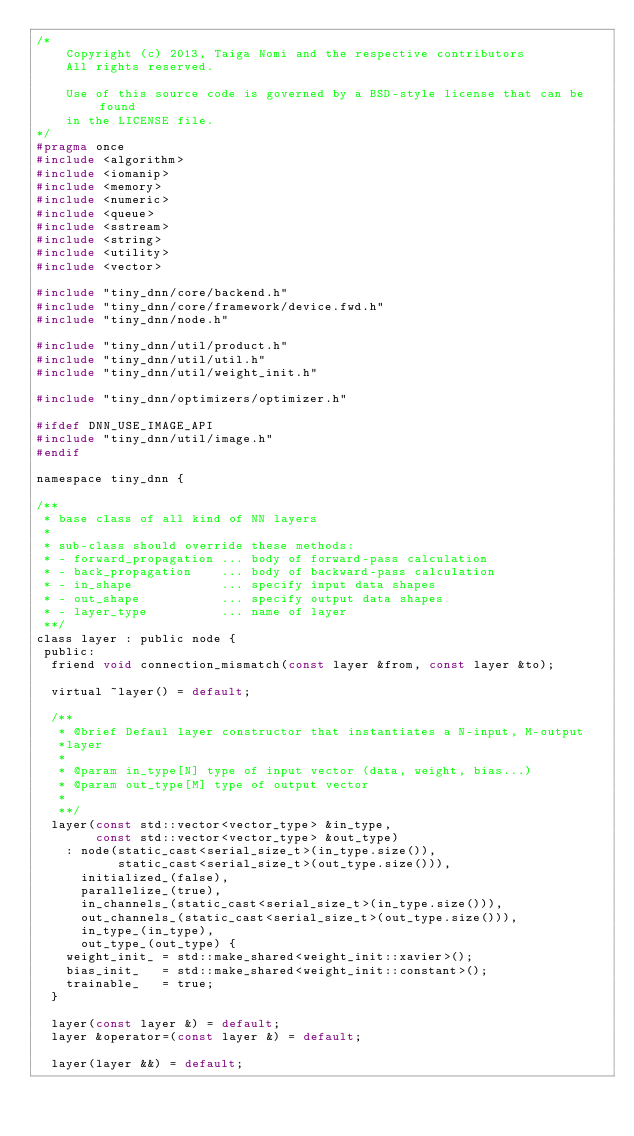<code> <loc_0><loc_0><loc_500><loc_500><_C_>/*
    Copyright (c) 2013, Taiga Nomi and the respective contributors
    All rights reserved.

    Use of this source code is governed by a BSD-style license that can be found
    in the LICENSE file.
*/
#pragma once
#include <algorithm>
#include <iomanip>
#include <memory>
#include <numeric>
#include <queue>
#include <sstream>
#include <string>
#include <utility>
#include <vector>

#include "tiny_dnn/core/backend.h"
#include "tiny_dnn/core/framework/device.fwd.h"
#include "tiny_dnn/node.h"

#include "tiny_dnn/util/product.h"
#include "tiny_dnn/util/util.h"
#include "tiny_dnn/util/weight_init.h"

#include "tiny_dnn/optimizers/optimizer.h"

#ifdef DNN_USE_IMAGE_API
#include "tiny_dnn/util/image.h"
#endif

namespace tiny_dnn {

/**
 * base class of all kind of NN layers
 *
 * sub-class should override these methods:
 * - forward_propagation ... body of forward-pass calculation
 * - back_propagation    ... body of backward-pass calculation
 * - in_shape            ... specify input data shapes
 * - out_shape           ... specify output data shapes
 * - layer_type          ... name of layer
 **/
class layer : public node {
 public:
  friend void connection_mismatch(const layer &from, const layer &to);

  virtual ~layer() = default;

  /**
   * @brief Defaul layer constructor that instantiates a N-input, M-output
   *layer
   *
   * @param in_type[N] type of input vector (data, weight, bias...)
   * @param out_type[M] type of output vector
   *
   **/
  layer(const std::vector<vector_type> &in_type,
        const std::vector<vector_type> &out_type)
    : node(static_cast<serial_size_t>(in_type.size()),
           static_cast<serial_size_t>(out_type.size())),
      initialized_(false),
      parallelize_(true),
      in_channels_(static_cast<serial_size_t>(in_type.size())),
      out_channels_(static_cast<serial_size_t>(out_type.size())),
      in_type_(in_type),
      out_type_(out_type) {
    weight_init_ = std::make_shared<weight_init::xavier>();
    bias_init_   = std::make_shared<weight_init::constant>();
    trainable_   = true;
  }

  layer(const layer &) = default;
  layer &operator=(const layer &) = default;

  layer(layer &&) = default;</code> 